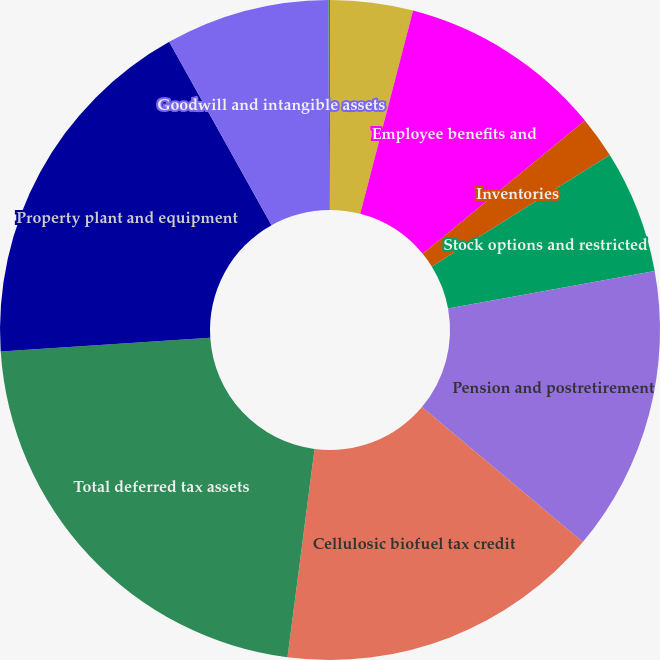<chart> <loc_0><loc_0><loc_500><loc_500><pie_chart><fcel>Accrued liabilities<fcel>Employee benefits and<fcel>Inventories<fcel>Stock options and restricted<fcel>Pension and postretirement<fcel>Cellulosic biofuel tax credit<fcel>Total deferred tax assets<fcel>Property plant and equipment<fcel>Goodwill and intangible assets<fcel>Investment in joint venture<nl><fcel>4.05%<fcel>10.0%<fcel>2.06%<fcel>6.03%<fcel>13.97%<fcel>15.95%<fcel>21.91%<fcel>17.94%<fcel>8.02%<fcel>0.08%<nl></chart> 